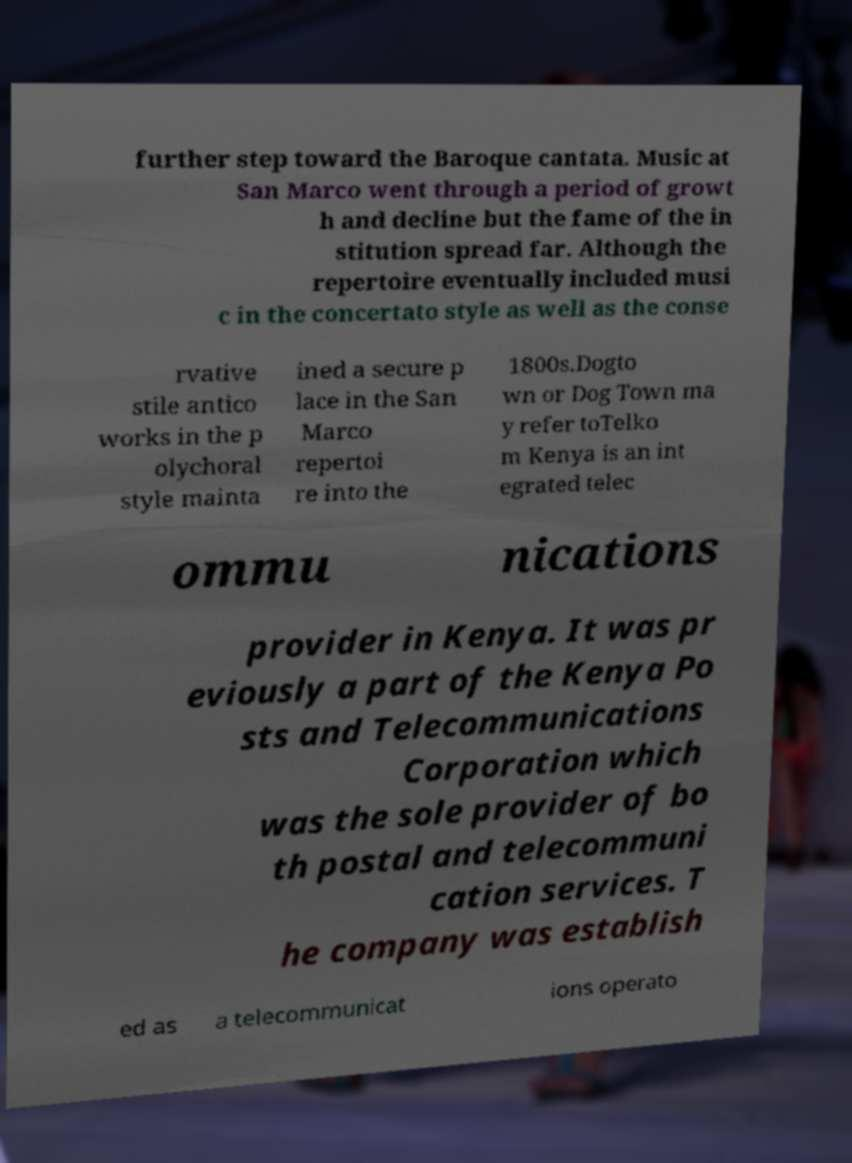Can you accurately transcribe the text from the provided image for me? further step toward the Baroque cantata. Music at San Marco went through a period of growt h and decline but the fame of the in stitution spread far. Although the repertoire eventually included musi c in the concertato style as well as the conse rvative stile antico works in the p olychoral style mainta ined a secure p lace in the San Marco repertoi re into the 1800s.Dogto wn or Dog Town ma y refer toTelko m Kenya is an int egrated telec ommu nications provider in Kenya. It was pr eviously a part of the Kenya Po sts and Telecommunications Corporation which was the sole provider of bo th postal and telecommuni cation services. T he company was establish ed as a telecommunicat ions operato 